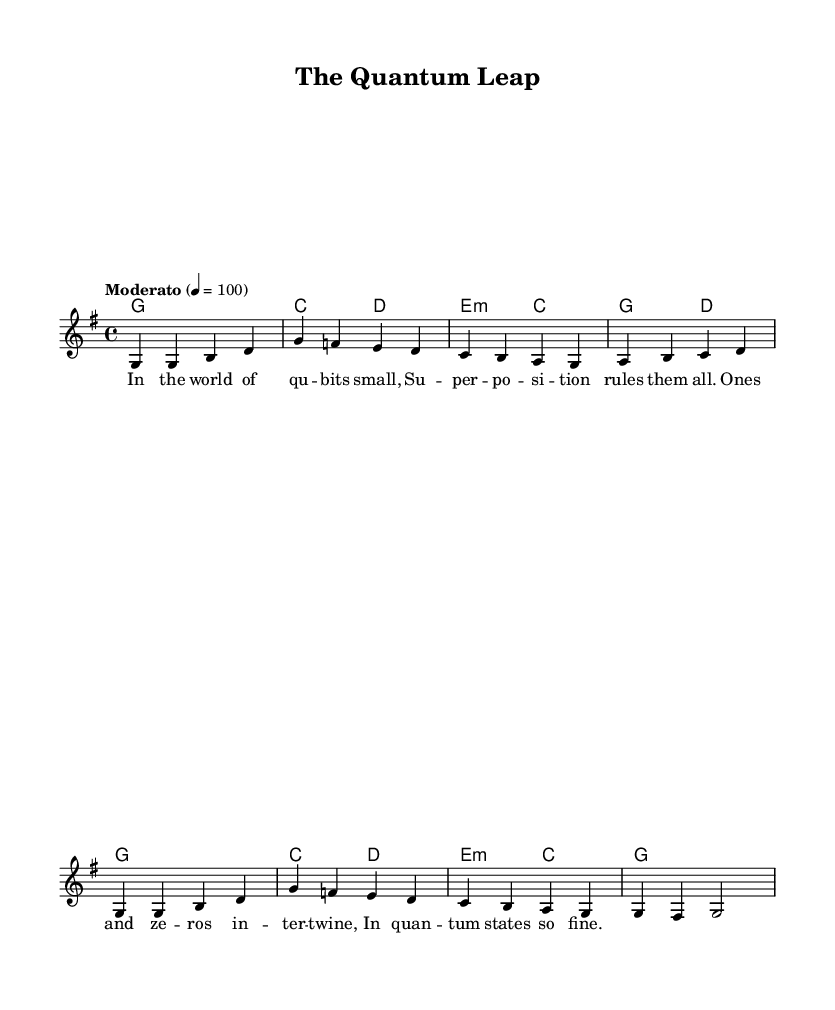What is the key signature of this music? The key signature is G major, indicated by the presence of one sharp (F#) in the key signature section of the sheet music.
Answer: G major What is the time signature of this music? The time signature is 4/4, which is shown at the beginning of the score and indicates that there are four beats in each measure.
Answer: 4/4 What is the tempo of this piece? The tempo marking "Moderato" means that it should be played at a moderate speed, and it is further defined with a metronome marking of 100 beats per minute.
Answer: Moderato How many measures are in the melody? The melody comprises eight measures, as counted visually in the staff where each measure is separated by vertical bar lines.
Answer: Eight In which verse do the lyrics mention superposition? The lyrics reference superposition in the first verse, specifically in the second line where it states "Superposition rules them all."
Answer: First What is the relationship between qubits and the lyrics? The lyrics mention "qubits" in the context of their small size and the rules of superposition that govern their behavior, emphasizing the quantum nature of these bits.
Answer: Quantum nature How is this piece categorized within folk traditions? This piece can be categorized as a modern folk tune, as it adapts traditional folk structures and melodies to explain complex technological concepts, making it accessible and educational.
Answer: Modern folk tune 